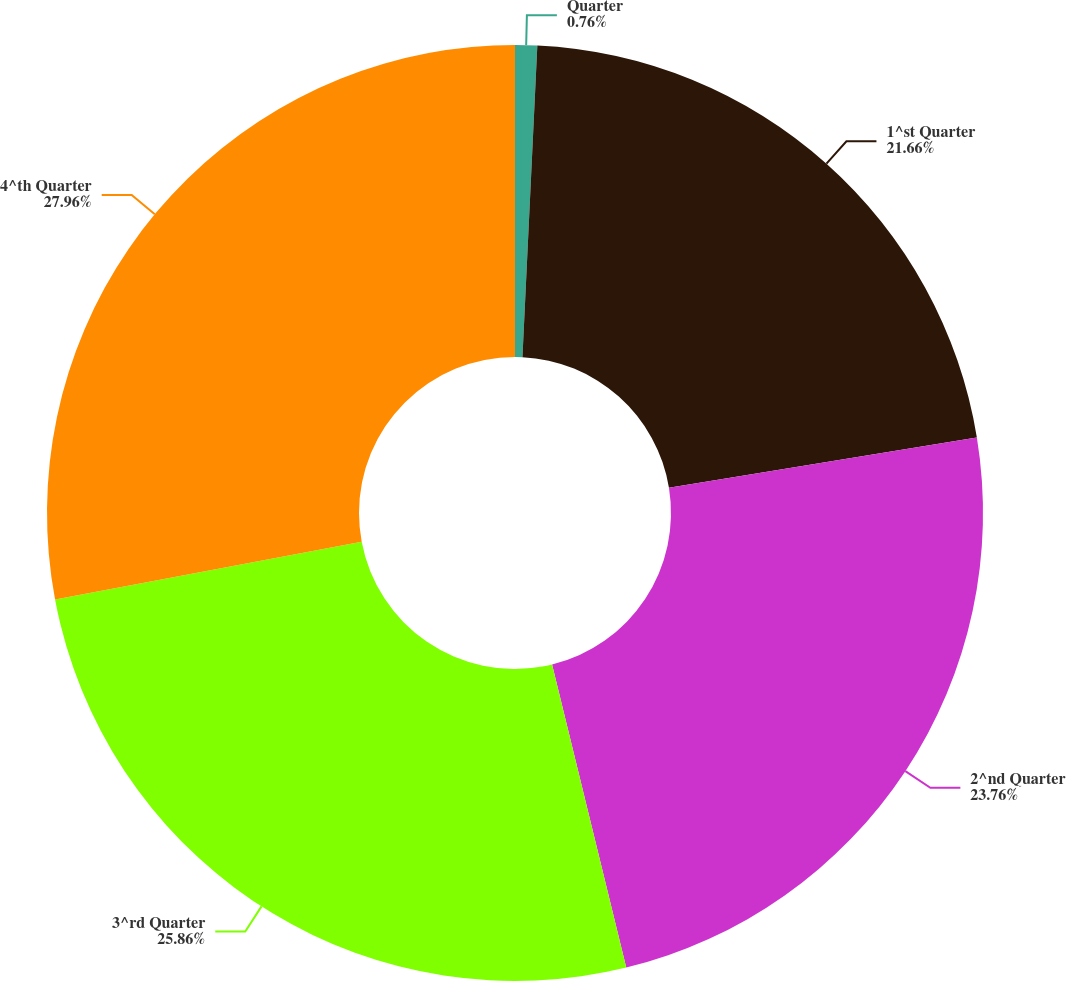Convert chart to OTSL. <chart><loc_0><loc_0><loc_500><loc_500><pie_chart><fcel>Quarter<fcel>1^st Quarter<fcel>2^nd Quarter<fcel>3^rd Quarter<fcel>4^th Quarter<nl><fcel>0.76%<fcel>21.66%<fcel>23.76%<fcel>25.86%<fcel>27.96%<nl></chart> 